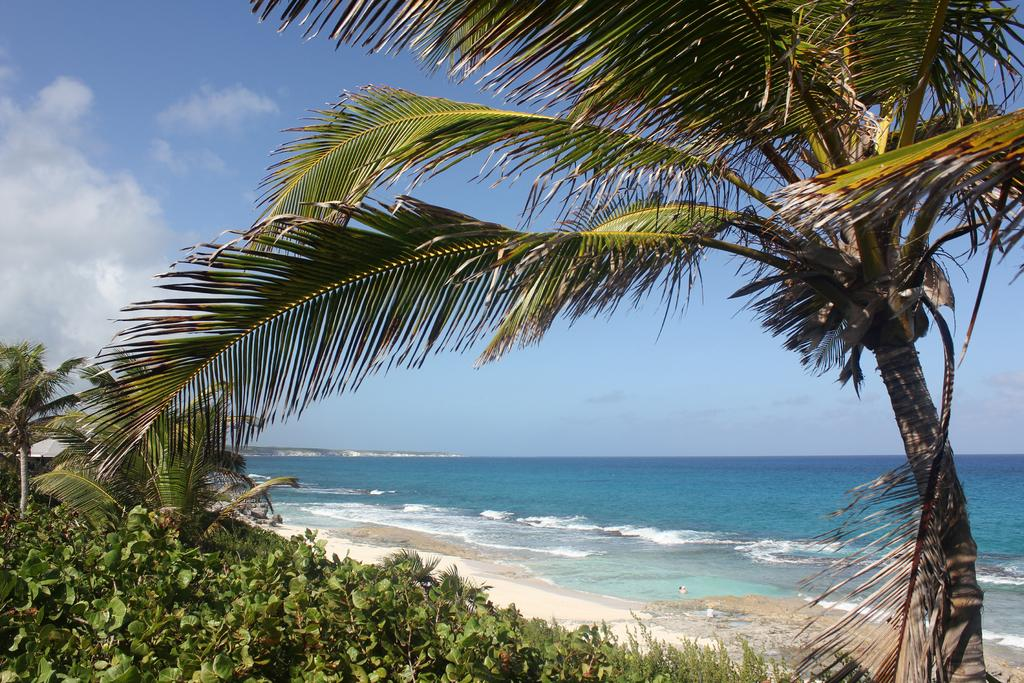What type of vegetation can be seen in the image? There is a tree and plants visible in the image. What type of terrain is present in the image? There is sand and water visible in the image. What is the color of the sky in the image? The sky is visible in the image. What type of shelter is present in the image? There is a tent in the image. What is the color of the tent in the image? The tent is ash in color. How many stitches are visible on the tent in the image? There is no mention of stitches on the tent in the image, so it is not possible to answer this question. What time of day is depicted in the image? The provided facts do not mention the time of day, so it is not possible to determine if it is day or night in the image. 